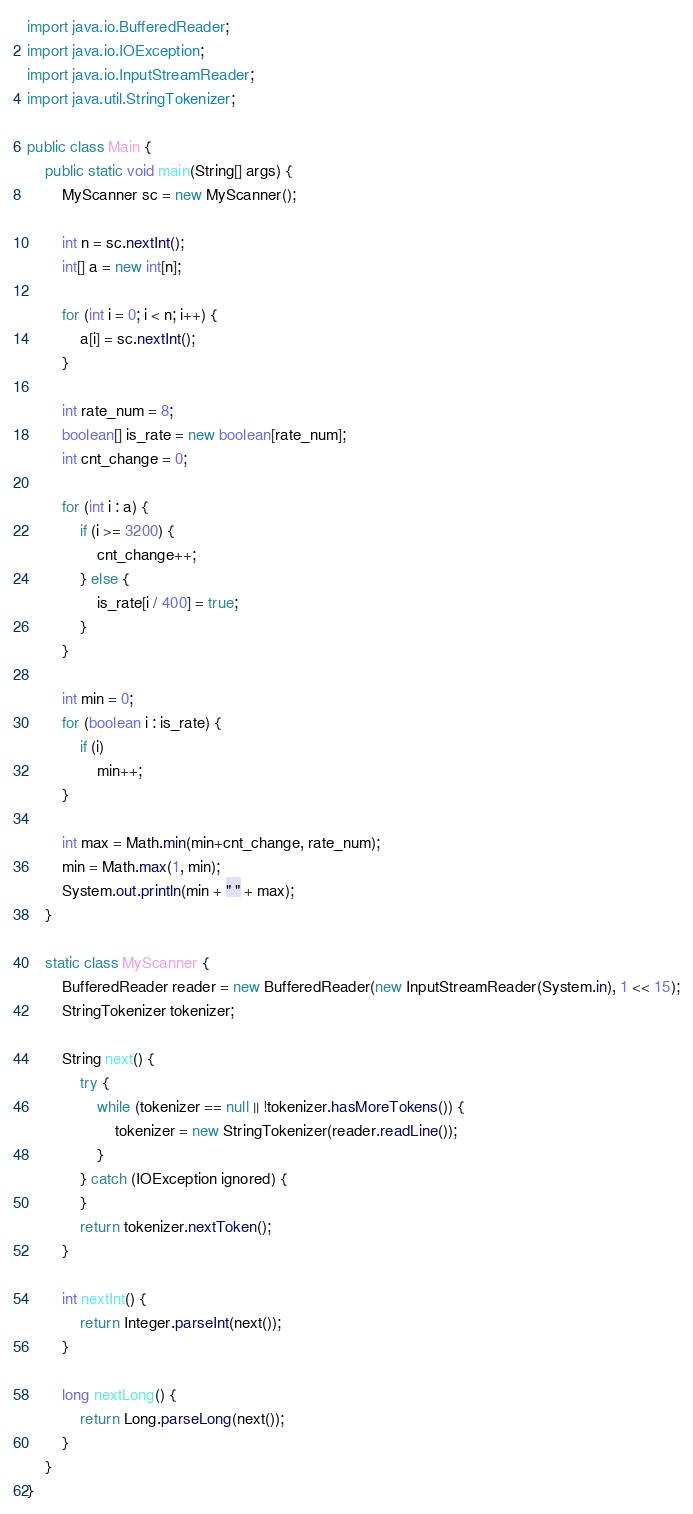Convert code to text. <code><loc_0><loc_0><loc_500><loc_500><_Java_>import java.io.BufferedReader;
import java.io.IOException;
import java.io.InputStreamReader;
import java.util.StringTokenizer;

public class Main {
    public static void main(String[] args) {
        MyScanner sc = new MyScanner();

        int n = sc.nextInt();
        int[] a = new int[n];

        for (int i = 0; i < n; i++) {
            a[i] = sc.nextInt();
        }

        int rate_num = 8;
        boolean[] is_rate = new boolean[rate_num];
        int cnt_change = 0;

        for (int i : a) {
            if (i >= 3200) {
                cnt_change++;
            } else {
                is_rate[i / 400] = true;
            }
        }

        int min = 0;
        for (boolean i : is_rate) {
            if (i)
                min++;
        }

        int max = Math.min(min+cnt_change, rate_num);
        min = Math.max(1, min);
        System.out.println(min + " " + max);
    }

    static class MyScanner {
        BufferedReader reader = new BufferedReader(new InputStreamReader(System.in), 1 << 15);
        StringTokenizer tokenizer;

        String next() {
            try {
                while (tokenizer == null || !tokenizer.hasMoreTokens()) {
                    tokenizer = new StringTokenizer(reader.readLine());
                }
            } catch (IOException ignored) {
            }
            return tokenizer.nextToken();
        }

        int nextInt() {
            return Integer.parseInt(next());
        }

        long nextLong() {
            return Long.parseLong(next());
        }
    }
}
</code> 